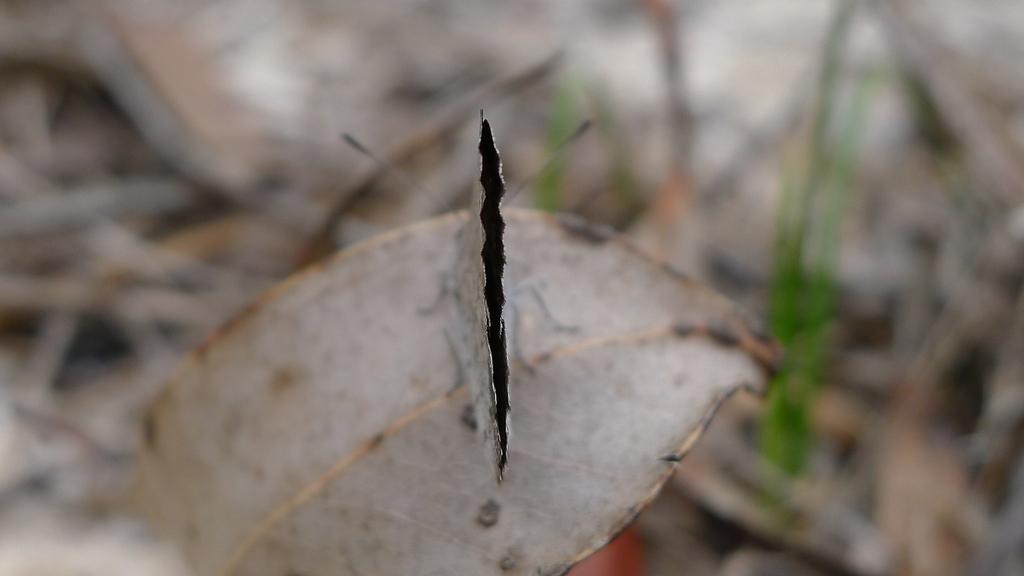Please provide a concise description of this image. In the image we can see there is a butterfly sitting on the dry leaf and background of the image is blurred. 